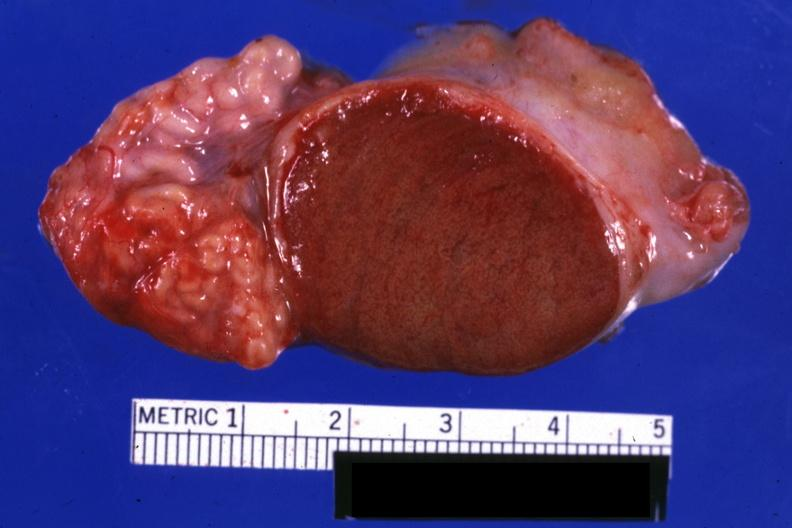s testicle present?
Answer the question using a single word or phrase. Yes 